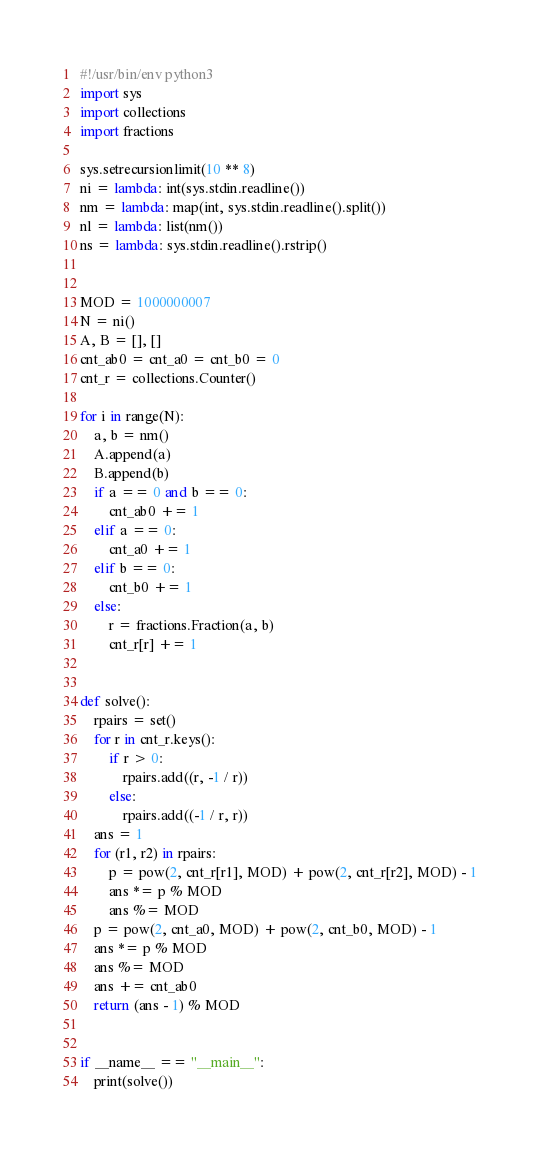<code> <loc_0><loc_0><loc_500><loc_500><_Python_>#!/usr/bin/env python3
import sys
import collections
import fractions

sys.setrecursionlimit(10 ** 8)
ni = lambda: int(sys.stdin.readline())
nm = lambda: map(int, sys.stdin.readline().split())
nl = lambda: list(nm())
ns = lambda: sys.stdin.readline().rstrip()


MOD = 1000000007
N = ni()
A, B = [], []
cnt_ab0 = cnt_a0 = cnt_b0 = 0
cnt_r = collections.Counter()

for i in range(N):
    a, b = nm()
    A.append(a)
    B.append(b)
    if a == 0 and b == 0:
        cnt_ab0 += 1
    elif a == 0:
        cnt_a0 += 1
    elif b == 0:
        cnt_b0 += 1
    else:
        r = fractions.Fraction(a, b)
        cnt_r[r] += 1


def solve():
    rpairs = set()
    for r in cnt_r.keys():
        if r > 0:
            rpairs.add((r, -1 / r))
        else:
            rpairs.add((-1 / r, r))
    ans = 1
    for (r1, r2) in rpairs:
        p = pow(2, cnt_r[r1], MOD) + pow(2, cnt_r[r2], MOD) - 1
        ans *= p % MOD
        ans %= MOD
    p = pow(2, cnt_a0, MOD) + pow(2, cnt_b0, MOD) - 1
    ans *= p % MOD
    ans %= MOD
    ans += cnt_ab0
    return (ans - 1) % MOD


if __name__ == "__main__":
    print(solve())
</code> 